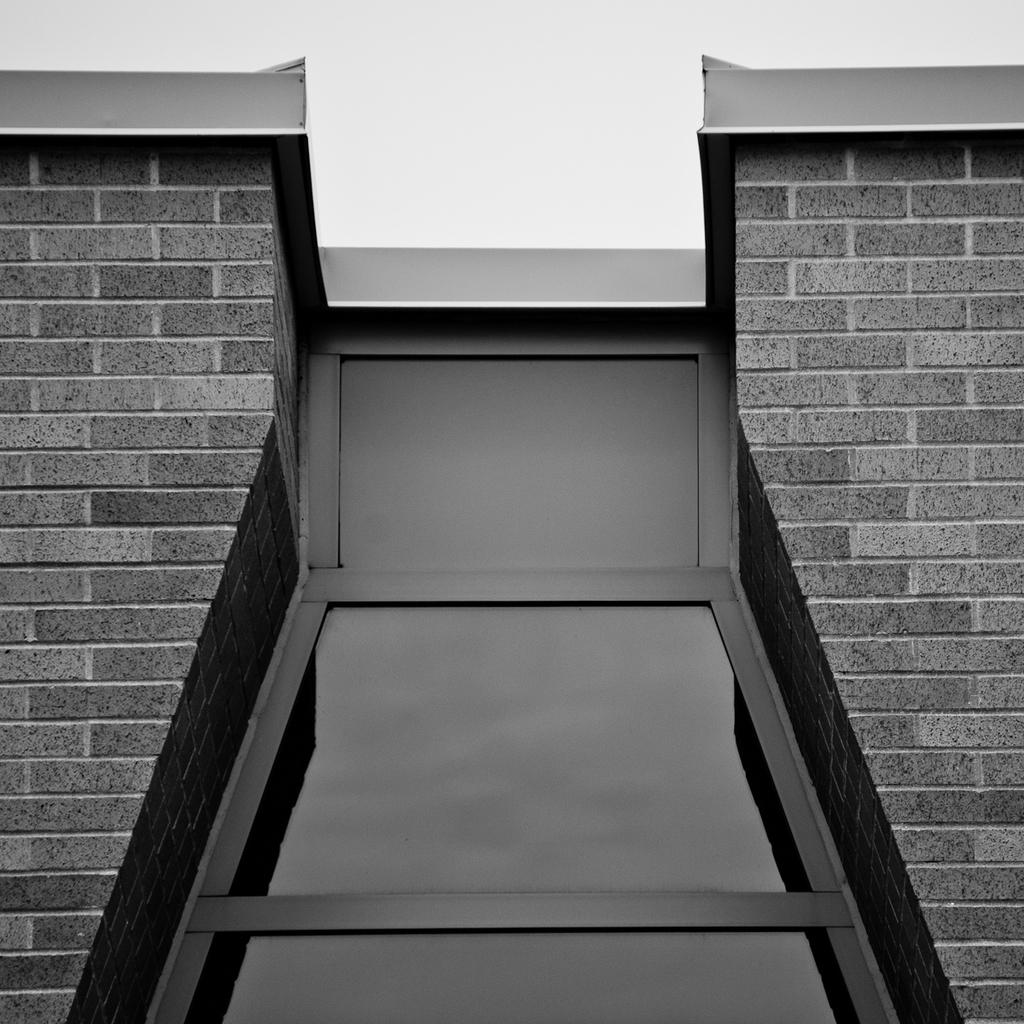What type of structure is present in the image? There is a building in the image. What part of the natural environment is visible in the image? The sky is visible in the image. What objects can be seen in the image besides the building and sky? There are glasses in the image. How many cars are parked in front of the building in the image? There is no information about cars in the image, so we cannot determine how many are parked in front of the building. 